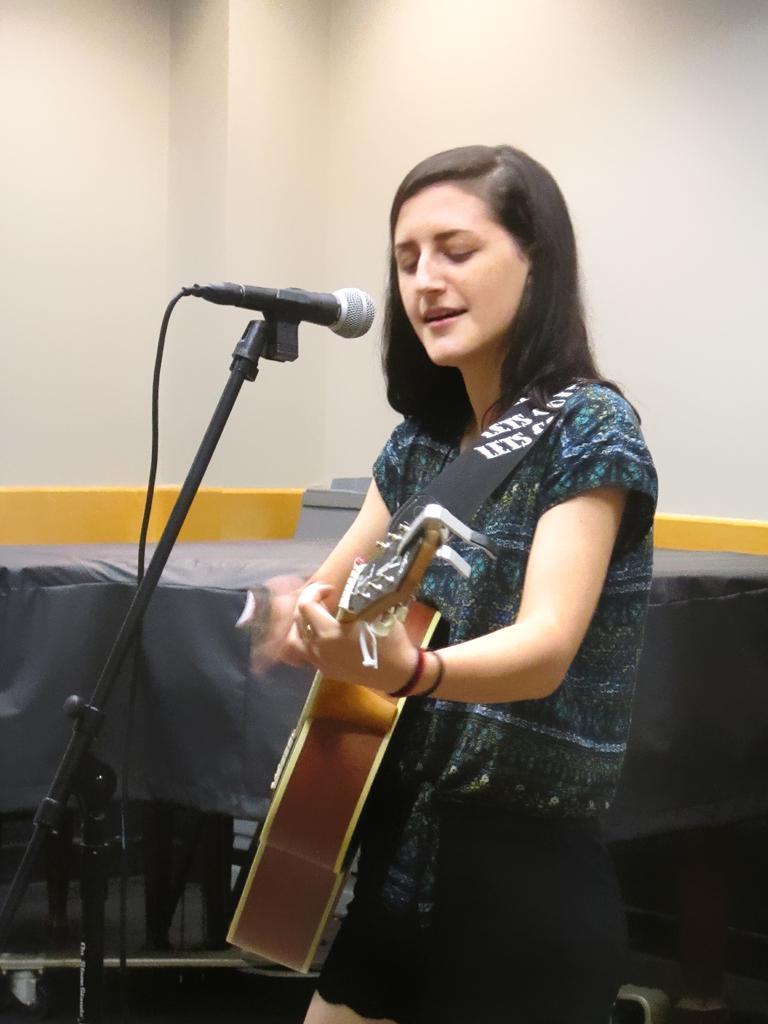Describe this image in one or two sentences. In this picture we can see a girl wearing blue color printed top and black skirt, Holding a guitar in her hand and singing in the microphone. Behind we can see white color wall. 